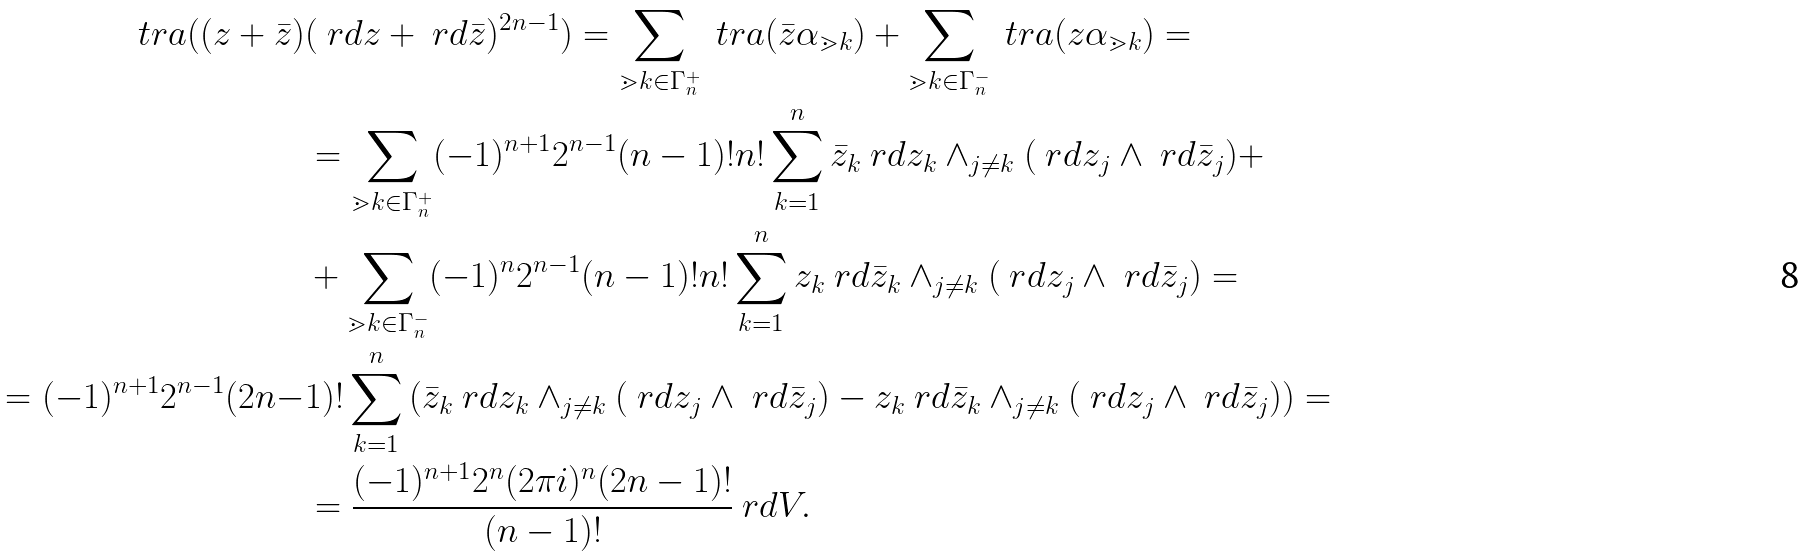<formula> <loc_0><loc_0><loc_500><loc_500>\ t r a ( ( z + \bar { z } ) & ( \ r d z + \ r d \bar { z } ) ^ { 2 n - 1 } ) = \sum _ { \mathbb { m } { k } \in \Gamma _ { n } ^ { + } } \ t r a ( \bar { z } \alpha _ { \mathbb { m } { k } } ) + \sum _ { \mathbb { m } { k } \in \Gamma _ { n } ^ { - } } \ t r a ( z \alpha _ { \mathbb { m } { k } } ) = \\ & = \sum _ { \mathbb { m } { k } \in \Gamma _ { n } ^ { + } } ( - 1 ) ^ { n + 1 } 2 ^ { n - 1 } ( n - 1 ) ! n ! \sum _ { k = 1 } ^ { n } \bar { z } _ { k } \ r d z _ { k } \wedge _ { j \neq k } ( \ r d z _ { j } \wedge \ r d \bar { z } _ { j } ) + \\ & + \sum _ { \mathbb { m } { k } \in \Gamma _ { n } ^ { - } } ( - 1 ) ^ { n } 2 ^ { n - 1 } ( n - 1 ) ! n ! \sum _ { k = 1 } ^ { n } z _ { k } \ r d \bar { z } _ { k } \wedge _ { j \neq k } ( \ r d z _ { j } \wedge \ r d \bar { z } _ { j } ) = \\ = ( - 1 ) ^ { n + 1 } 2 ^ { n - 1 } ( 2 n - & 1 ) ! \sum _ { k = 1 } ^ { n } \left ( \bar { z } _ { k } \ r d z _ { k } \wedge _ { j \neq k } ( \ r d z _ { j } \wedge \ r d \bar { z } _ { j } ) - z _ { k } \ r d \bar { z } _ { k } \wedge _ { j \neq k } ( \ r d z _ { j } \wedge \ r d \bar { z } _ { j } ) \right ) = \\ & = \frac { ( - 1 ) ^ { n + 1 } 2 ^ { n } ( 2 \pi i ) ^ { n } ( 2 n - 1 ) ! } { ( n - 1 ) ! } \ r d V .</formula> 